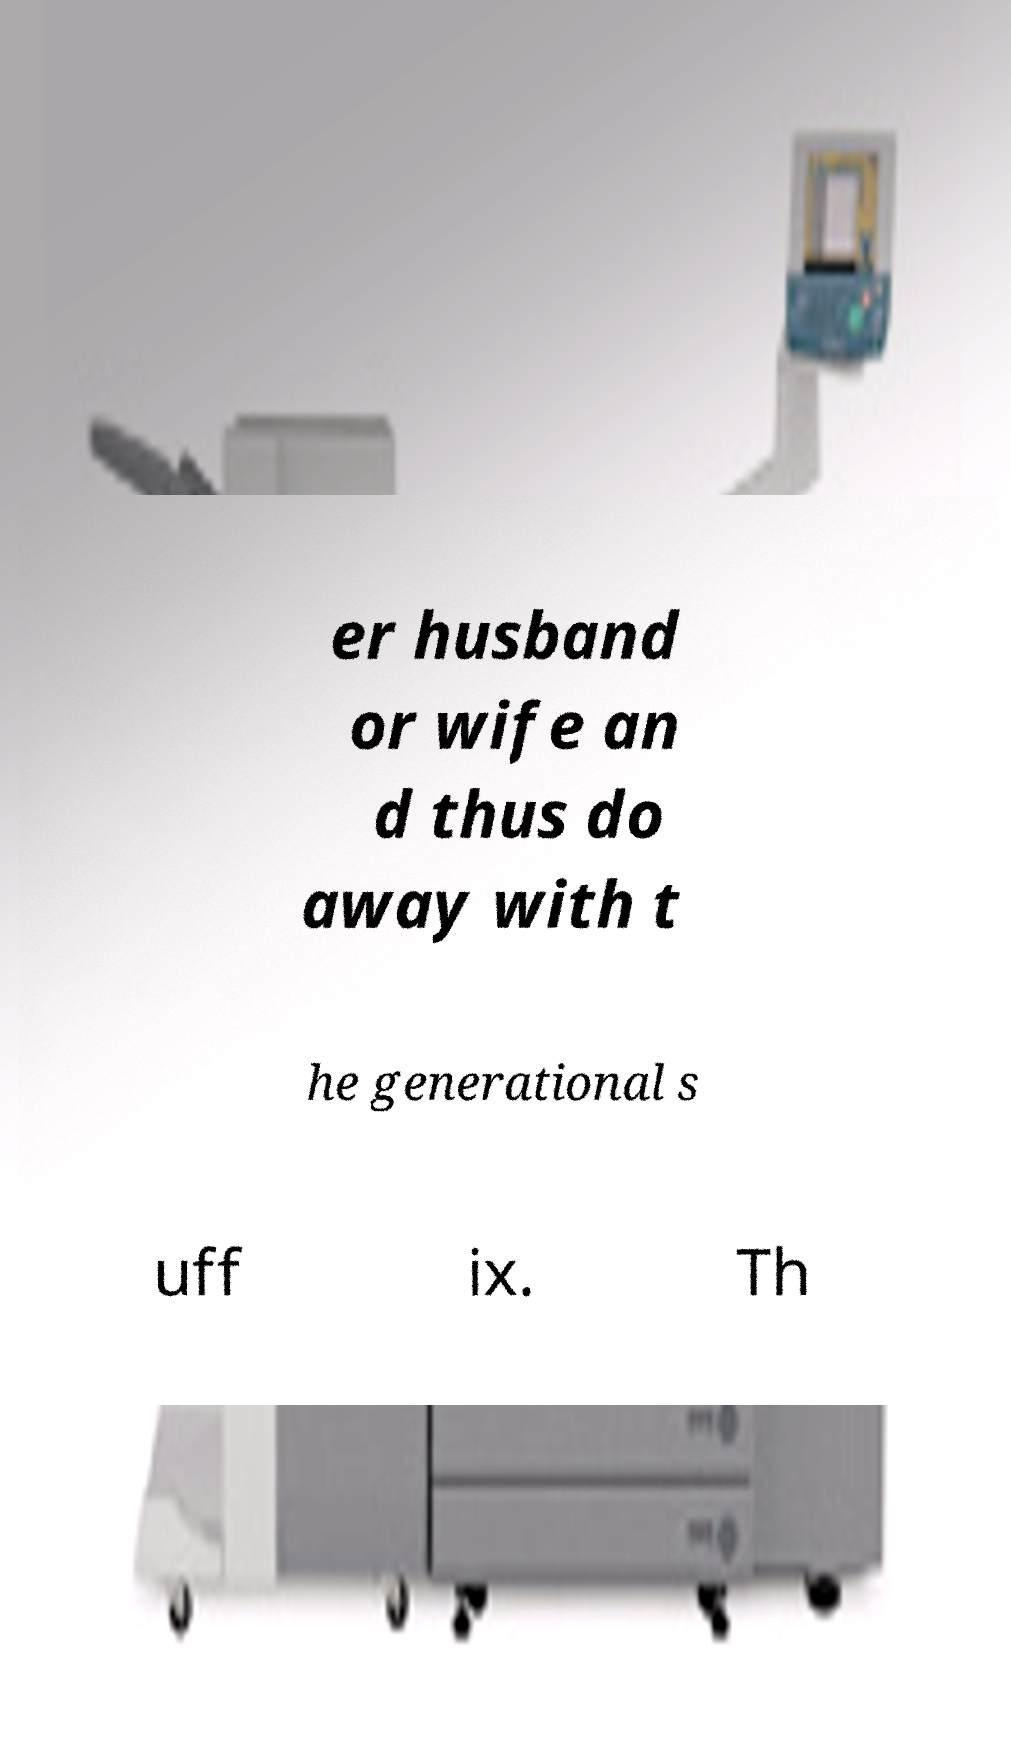Could you assist in decoding the text presented in this image and type it out clearly? er husband or wife an d thus do away with t he generational s uff ix. Th 